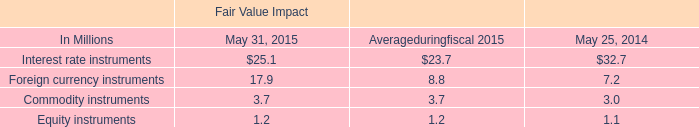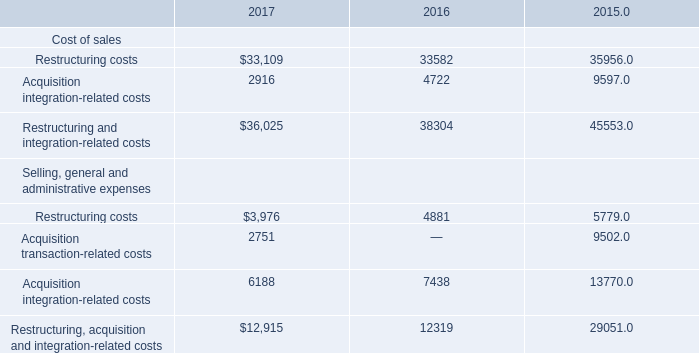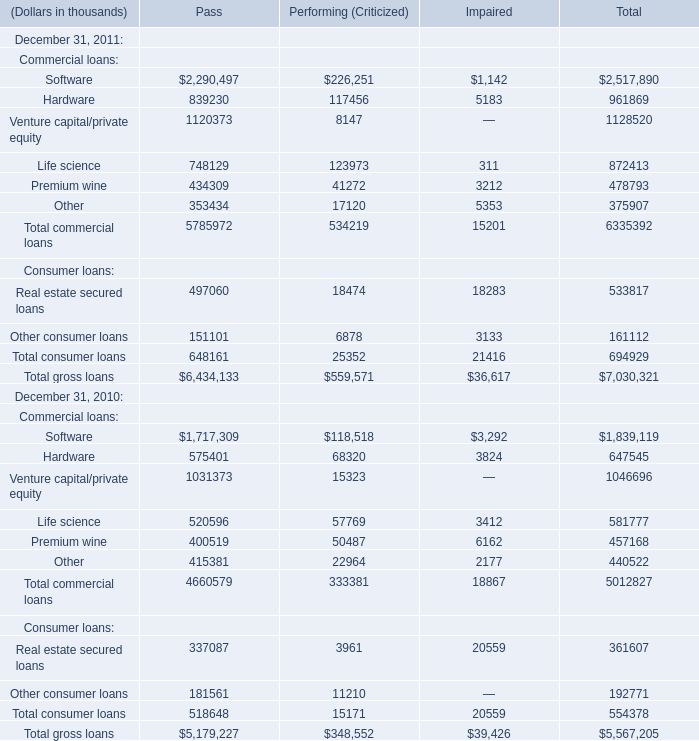What is the sum of Software of Impaired in 2011 and Acquisition integration-related costs in 2016? (in thousand) 
Computations: (1142 + 4722)
Answer: 5864.0. 